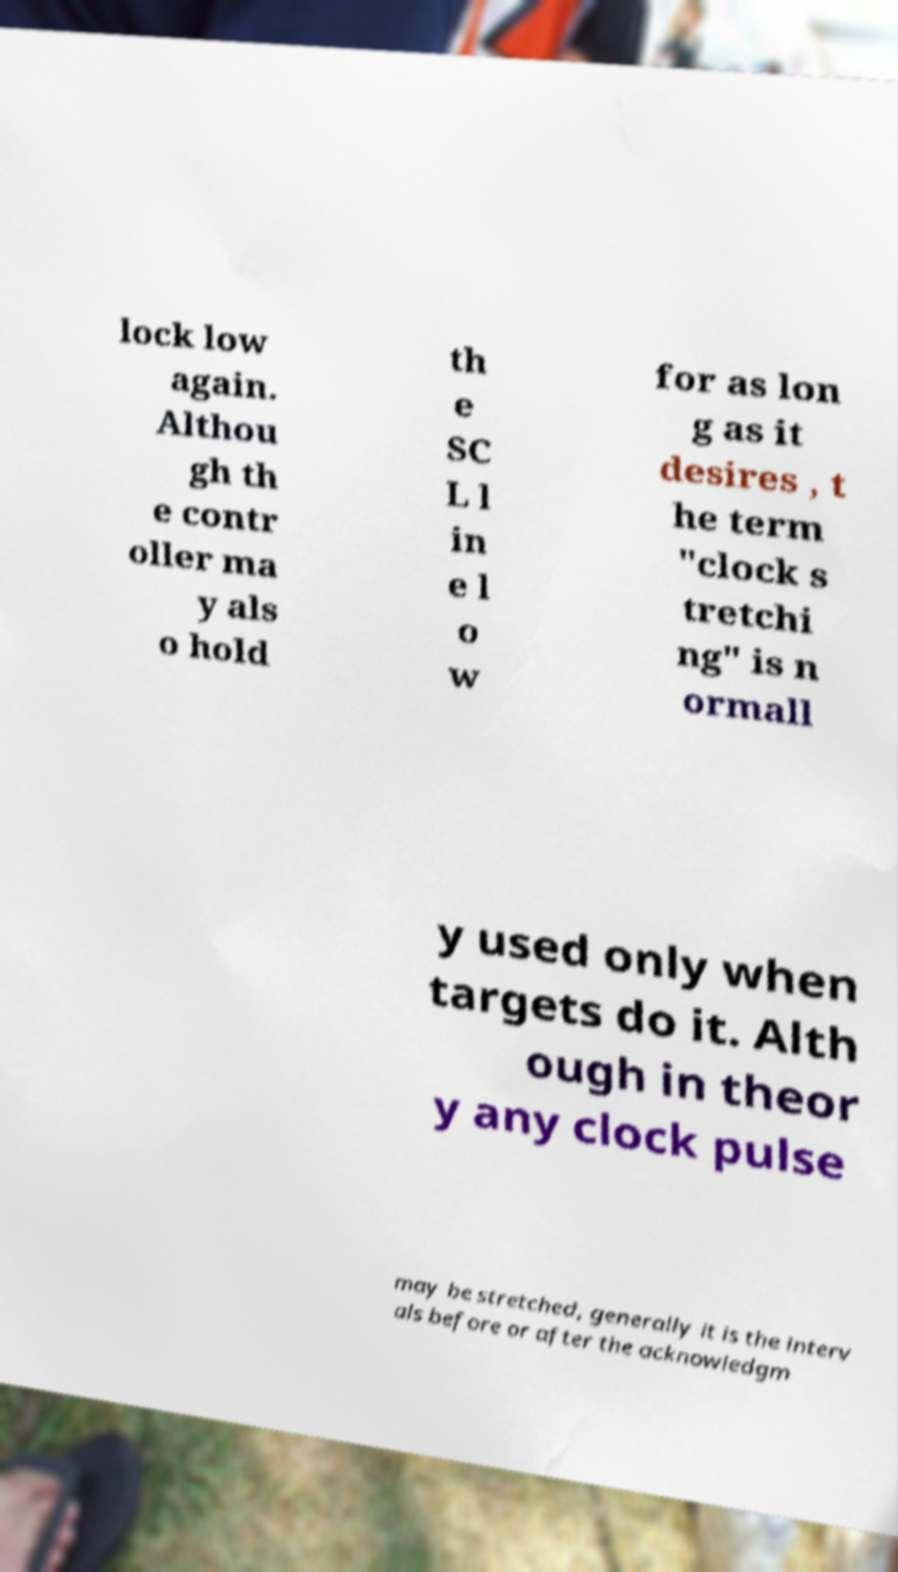What messages or text are displayed in this image? I need them in a readable, typed format. lock low again. Althou gh th e contr oller ma y als o hold th e SC L l in e l o w for as lon g as it desires , t he term "clock s tretchi ng" is n ormall y used only when targets do it. Alth ough in theor y any clock pulse may be stretched, generally it is the interv als before or after the acknowledgm 